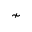Convert formula to latex. <formula><loc_0><loc_0><loc_500><loc_500>\nsim</formula> 